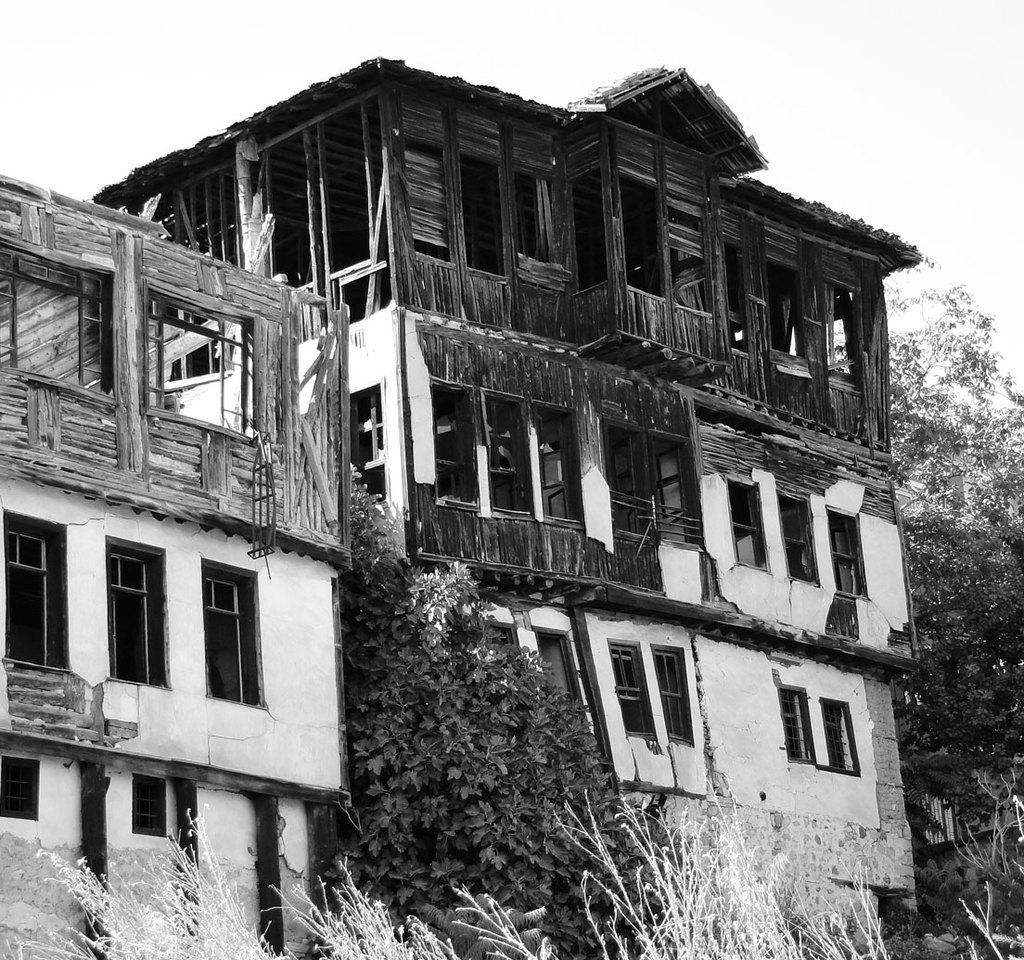What is the color scheme of the image? The image is black and white. What type of buildings can be seen in the image? There are two partially constructed buildings made of wood. What is located between the buildings? There are trees between the buildings. What type of vegetation is in front of the buildings? There is grass in the front of the buildings. What type of nut can be seen growing on the trees in the image? There are no nuts visible on the trees in the image; only trees are present. 